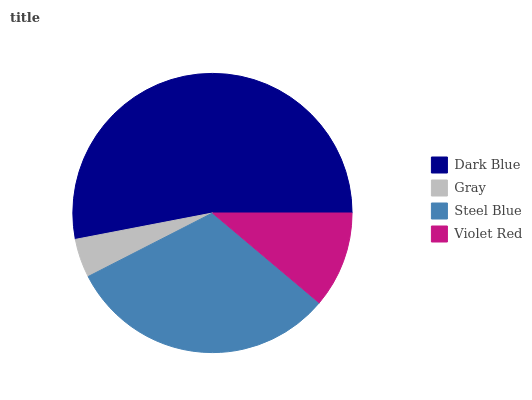Is Gray the minimum?
Answer yes or no. Yes. Is Dark Blue the maximum?
Answer yes or no. Yes. Is Steel Blue the minimum?
Answer yes or no. No. Is Steel Blue the maximum?
Answer yes or no. No. Is Steel Blue greater than Gray?
Answer yes or no. Yes. Is Gray less than Steel Blue?
Answer yes or no. Yes. Is Gray greater than Steel Blue?
Answer yes or no. No. Is Steel Blue less than Gray?
Answer yes or no. No. Is Steel Blue the high median?
Answer yes or no. Yes. Is Violet Red the low median?
Answer yes or no. Yes. Is Dark Blue the high median?
Answer yes or no. No. Is Steel Blue the low median?
Answer yes or no. No. 